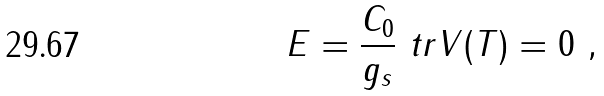Convert formula to latex. <formula><loc_0><loc_0><loc_500><loc_500>E = \frac { C _ { 0 } } { g _ { s } } \ t r V ( T ) = 0 \ ,</formula> 